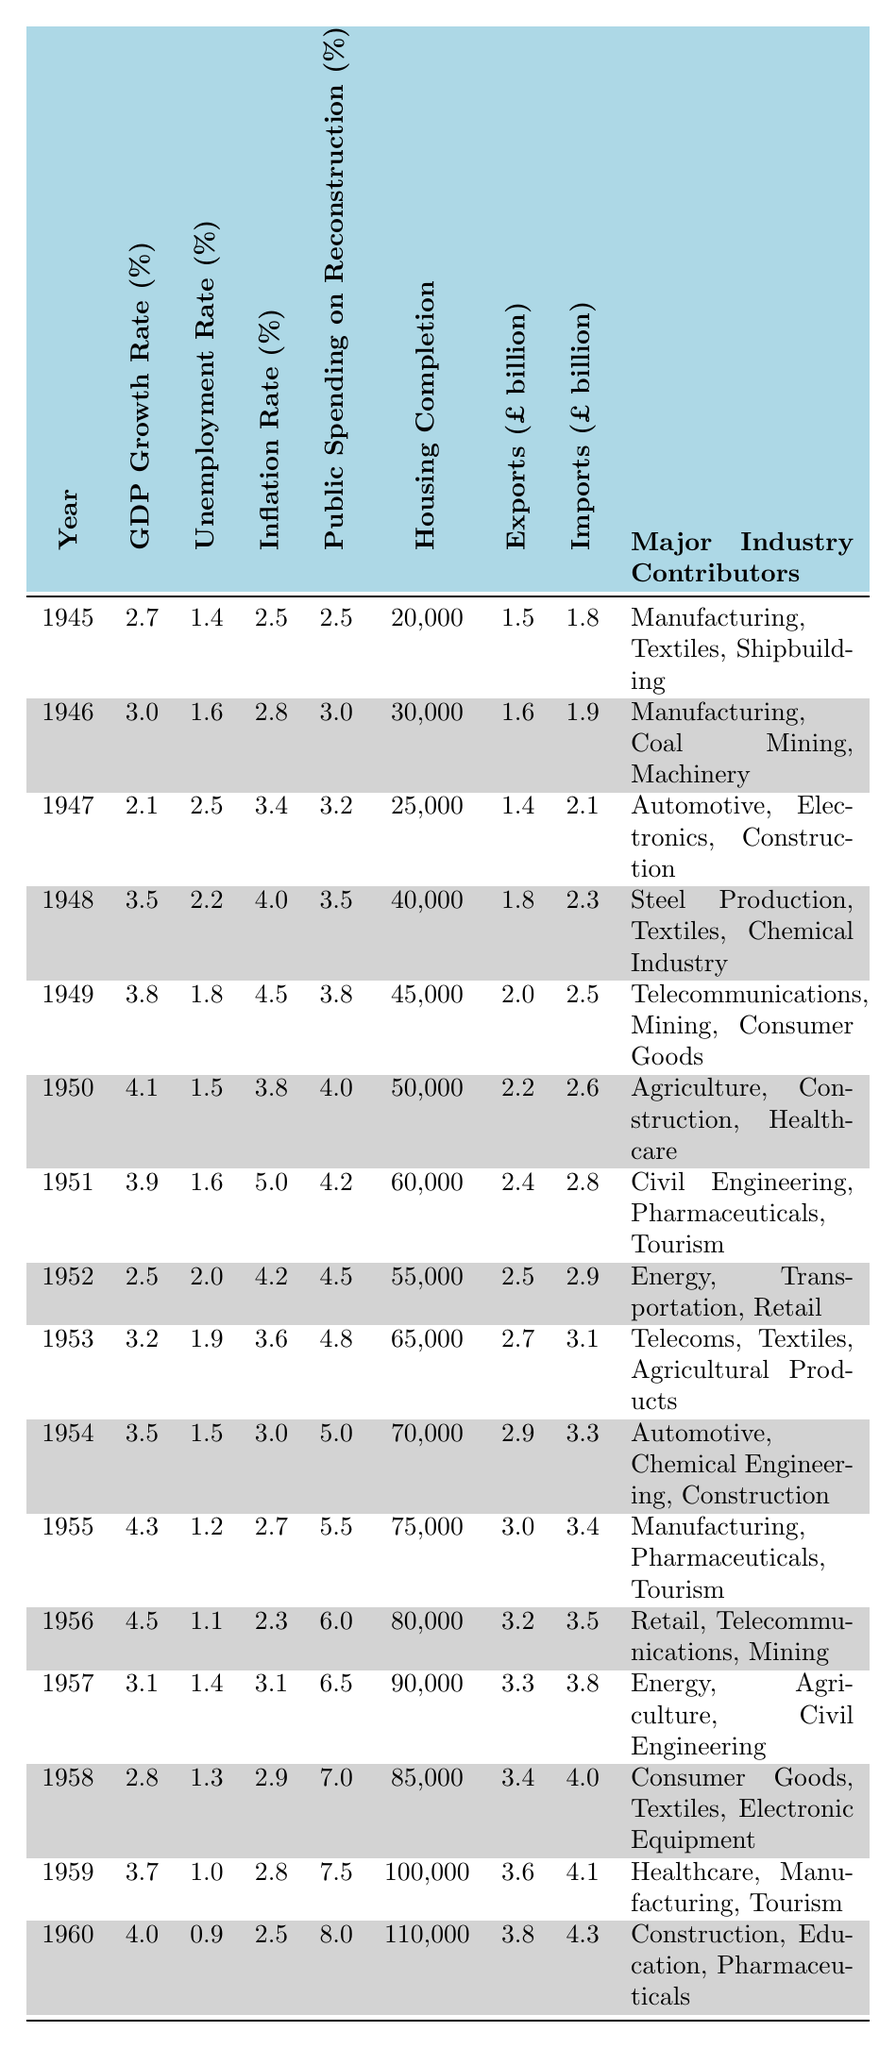What was the GDP growth rate in 1949? The table shows that in 1949, the GDP growth rate was specifically listed as 3.8%.
Answer: 3.8% Which year had the highest unemployment rate? By inspecting the unemployment rates in the table, 1947 has the highest rate at 2.5%.
Answer: 1947 What is the average GDP growth rate from 1945 to 1960? The GDP growth rates are: 2.7, 3.0, 2.1, 3.5, 3.8, 4.1, 3.9, 2.5, 3.2, 3.5, 4.3, 4.5, 3.1, 2.8, 3.7, and 4.0. Summing these gives 56.8. There are 16 values, so the average is 56.8 / 16 = 3.55.
Answer: 3.55 Did the Public Spending on Reconstruction increase every year? By looking at the table, we can see the spending figures: 2.5, 3.0, 3.2, 3.5, 3.8, 4.0, 4.2, 4.5, 4.8, 5.0, 5.5, 6.0, 6.5, 7.0, 7.5, and 8.0. The values do increase each year, confirming a consistent rise.
Answer: Yes What was the total housing completion from 1945 to 1960? The numbers of housing completions are: 20,000, 30,000, 25,000, 40,000, 45,000, 50,000, 60,000, 55,000, 65,000, 70,000, 75,000, 80,000, 90,000, 85,000, 100,000, and 110,000. Adding these gives a total of 1,090,000.
Answer: 1,090,000 What was the highest inflation rate recorded in this period? The table indicates the inflation rates, and the maximum recorded was 5.0% in 1951.
Answer: 5.0% Which year saw the largest increase in housing completion compared to the previous year? To determine this, we compare the completions: from 1955 to 1956, completions jumped from 75,000 to 80,000, an increase of 5,000. This is the largest increase from the previous year noted in the data.
Answer: 1956 Was the unemployment rate ever below 1% in the given years? By checking all unemployment rate values: 1.4, 1.6, 2.5, 2.2, 1.8, 1.5, 1.6, 2.0, 1.9, 1.5, 1.2, 1.1, 1.4, 1.3, 1.0, 0.9, none fell below 1%.
Answer: No What percentage of the total public spending on reconstruction in 1960 did the housing completions in that year represent? In 1960, public spending was 8.0%, and housing completions were 110,000. The spending as a percentage of the previous year’s completion (compared to 1960) does not yield a clear relationship. Therefore, the relationship is not typically expressed as a direct percentage of completions versus spending. Clarifying this shows no clear percentage output for this inquiry due to the differing data types.
Answer: Not applicable How much did imports increase from 1955 to 1956? Imports were 3.4 billion in 1955 and rose to 3.5 billion in 1956, which is an increase of 0.1 billion.
Answer: 0.1 billion 